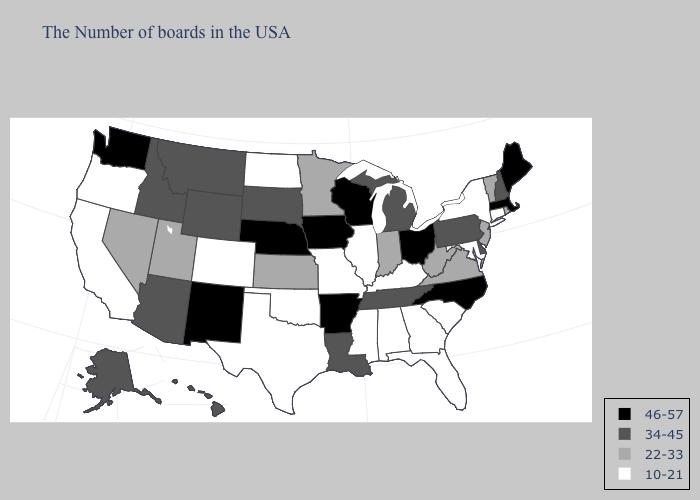What is the value of Massachusetts?
Keep it brief. 46-57. What is the lowest value in the USA?
Short answer required. 10-21. Does the map have missing data?
Keep it brief. No. Among the states that border Tennessee , does Virginia have the lowest value?
Short answer required. No. Does Minnesota have the same value as Tennessee?
Write a very short answer. No. Which states have the lowest value in the USA?
Short answer required. Connecticut, New York, Maryland, South Carolina, Florida, Georgia, Kentucky, Alabama, Illinois, Mississippi, Missouri, Oklahoma, Texas, North Dakota, Colorado, California, Oregon. Does Oregon have the lowest value in the West?
Quick response, please. Yes. Does New Hampshire have the highest value in the Northeast?
Keep it brief. No. Does Massachusetts have the highest value in the USA?
Answer briefly. Yes. Name the states that have a value in the range 22-33?
Concise answer only. Rhode Island, Vermont, New Jersey, Virginia, West Virginia, Indiana, Minnesota, Kansas, Utah, Nevada. What is the value of New Mexico?
Answer briefly. 46-57. Does the map have missing data?
Keep it brief. No. Is the legend a continuous bar?
Write a very short answer. No. Among the states that border Arkansas , which have the lowest value?
Keep it brief. Mississippi, Missouri, Oklahoma, Texas. 